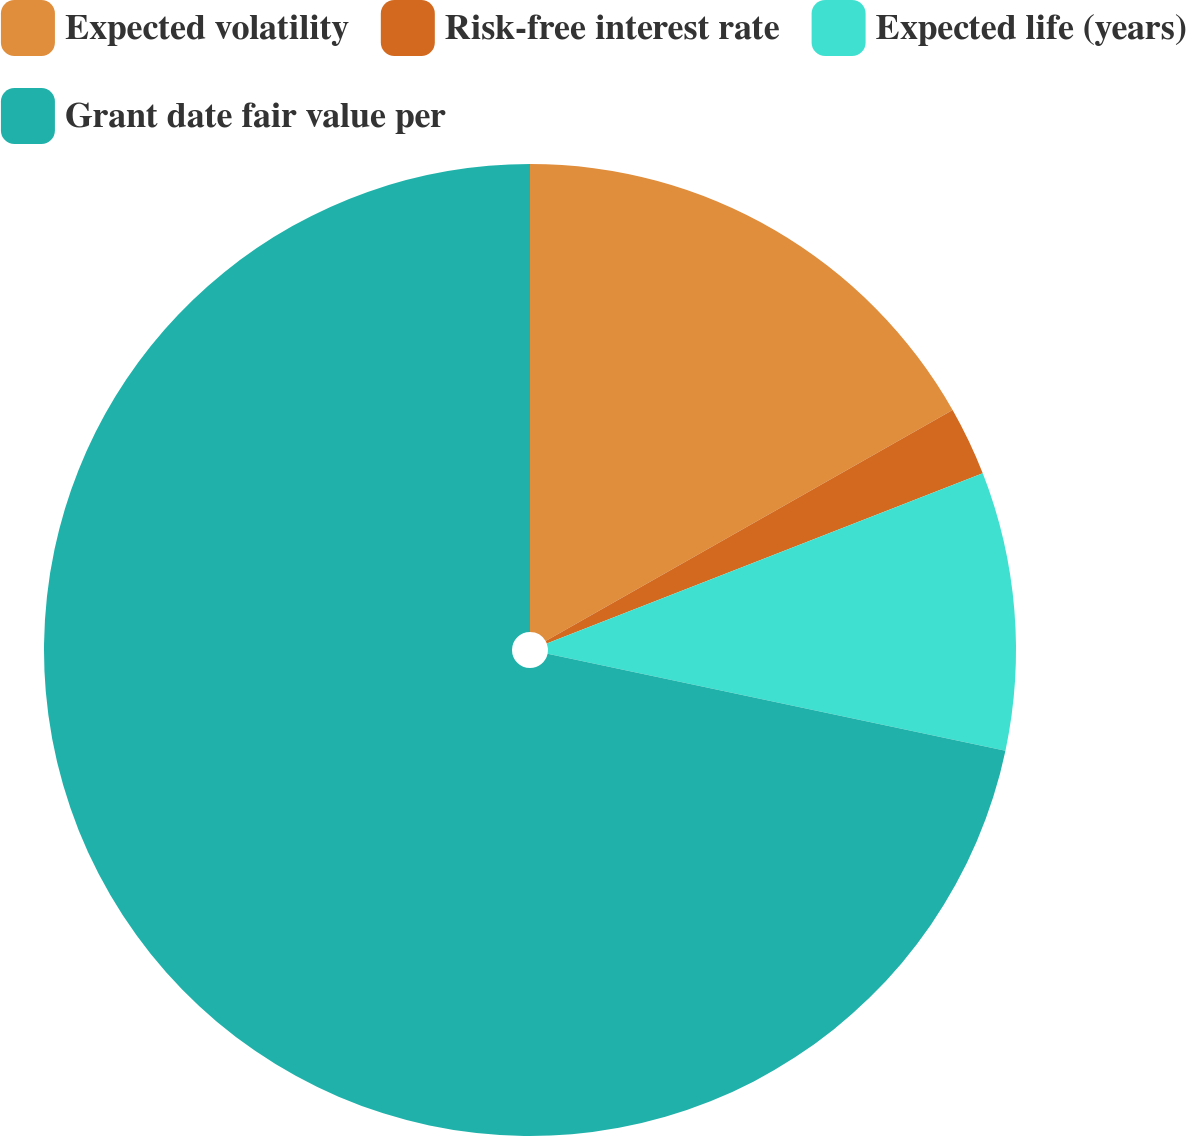Convert chart. <chart><loc_0><loc_0><loc_500><loc_500><pie_chart><fcel>Expected volatility<fcel>Risk-free interest rate<fcel>Expected life (years)<fcel>Grant date fair value per<nl><fcel>16.78%<fcel>2.3%<fcel>9.24%<fcel>71.68%<nl></chart> 